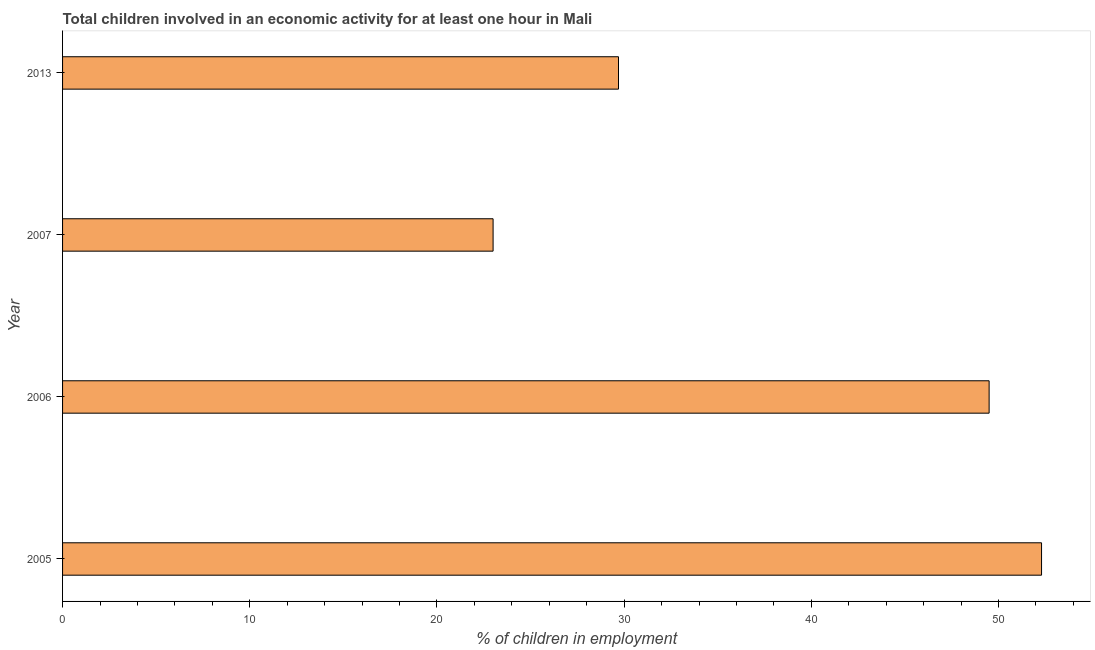Does the graph contain grids?
Your answer should be very brief. No. What is the title of the graph?
Keep it short and to the point. Total children involved in an economic activity for at least one hour in Mali. What is the label or title of the X-axis?
Ensure brevity in your answer.  % of children in employment. What is the label or title of the Y-axis?
Give a very brief answer. Year. What is the percentage of children in employment in 2005?
Provide a succinct answer. 52.3. Across all years, what is the maximum percentage of children in employment?
Your answer should be compact. 52.3. What is the sum of the percentage of children in employment?
Your answer should be compact. 154.5. What is the difference between the percentage of children in employment in 2006 and 2007?
Your answer should be compact. 26.5. What is the average percentage of children in employment per year?
Make the answer very short. 38.62. What is the median percentage of children in employment?
Your response must be concise. 39.6. In how many years, is the percentage of children in employment greater than 48 %?
Provide a short and direct response. 2. Do a majority of the years between 2006 and 2005 (inclusive) have percentage of children in employment greater than 36 %?
Give a very brief answer. No. What is the ratio of the percentage of children in employment in 2006 to that in 2013?
Your answer should be very brief. 1.67. Is the difference between the percentage of children in employment in 2005 and 2006 greater than the difference between any two years?
Keep it short and to the point. No. What is the difference between the highest and the lowest percentage of children in employment?
Give a very brief answer. 29.3. Are all the bars in the graph horizontal?
Provide a succinct answer. Yes. How many years are there in the graph?
Keep it short and to the point. 4. What is the difference between two consecutive major ticks on the X-axis?
Ensure brevity in your answer.  10. What is the % of children in employment of 2005?
Provide a succinct answer. 52.3. What is the % of children in employment in 2006?
Offer a terse response. 49.5. What is the % of children in employment in 2007?
Give a very brief answer. 23. What is the % of children in employment of 2013?
Provide a short and direct response. 29.7. What is the difference between the % of children in employment in 2005 and 2006?
Offer a terse response. 2.8. What is the difference between the % of children in employment in 2005 and 2007?
Ensure brevity in your answer.  29.3. What is the difference between the % of children in employment in 2005 and 2013?
Provide a succinct answer. 22.6. What is the difference between the % of children in employment in 2006 and 2013?
Keep it short and to the point. 19.8. What is the difference between the % of children in employment in 2007 and 2013?
Give a very brief answer. -6.7. What is the ratio of the % of children in employment in 2005 to that in 2006?
Ensure brevity in your answer.  1.06. What is the ratio of the % of children in employment in 2005 to that in 2007?
Offer a very short reply. 2.27. What is the ratio of the % of children in employment in 2005 to that in 2013?
Your response must be concise. 1.76. What is the ratio of the % of children in employment in 2006 to that in 2007?
Make the answer very short. 2.15. What is the ratio of the % of children in employment in 2006 to that in 2013?
Keep it short and to the point. 1.67. What is the ratio of the % of children in employment in 2007 to that in 2013?
Offer a terse response. 0.77. 